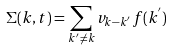Convert formula to latex. <formula><loc_0><loc_0><loc_500><loc_500>\Sigma ( { k } , t ) = \sum _ { { k } ^ { ^ { \prime } } \neq { k } } v _ { { k } - { k } ^ { ^ { \prime } } } f ( { k } ^ { ^ { \prime } } )</formula> 